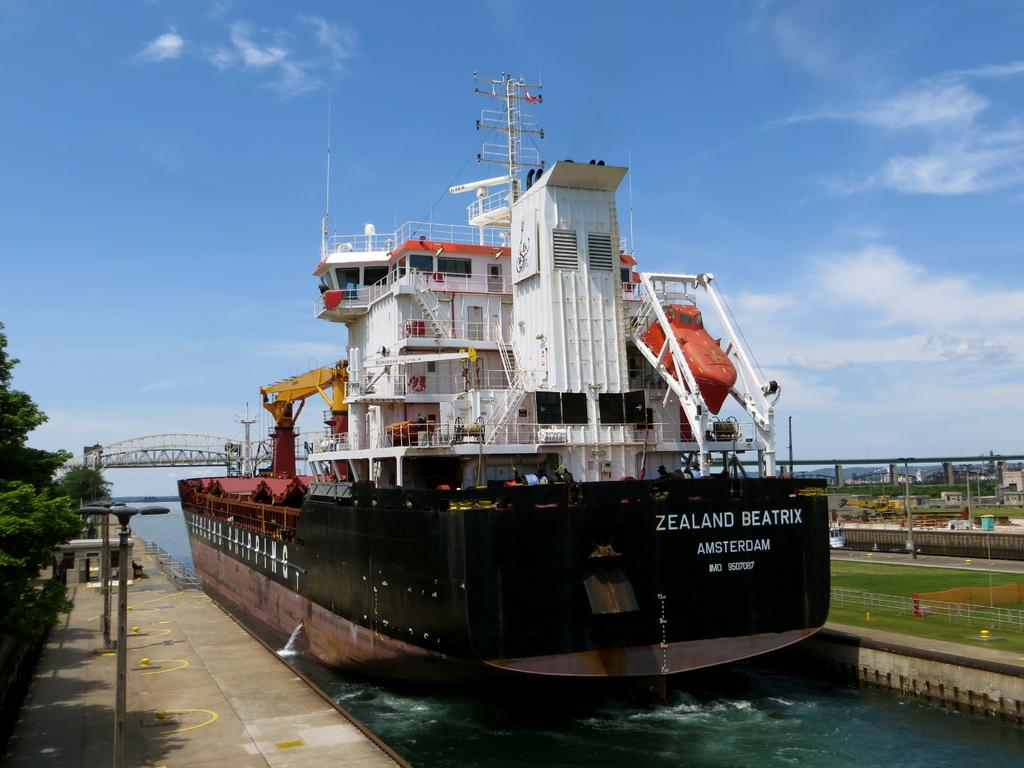<image>
Create a compact narrative representing the image presented. A ship is from Amsterdam is docked with a blue sky in the background. 